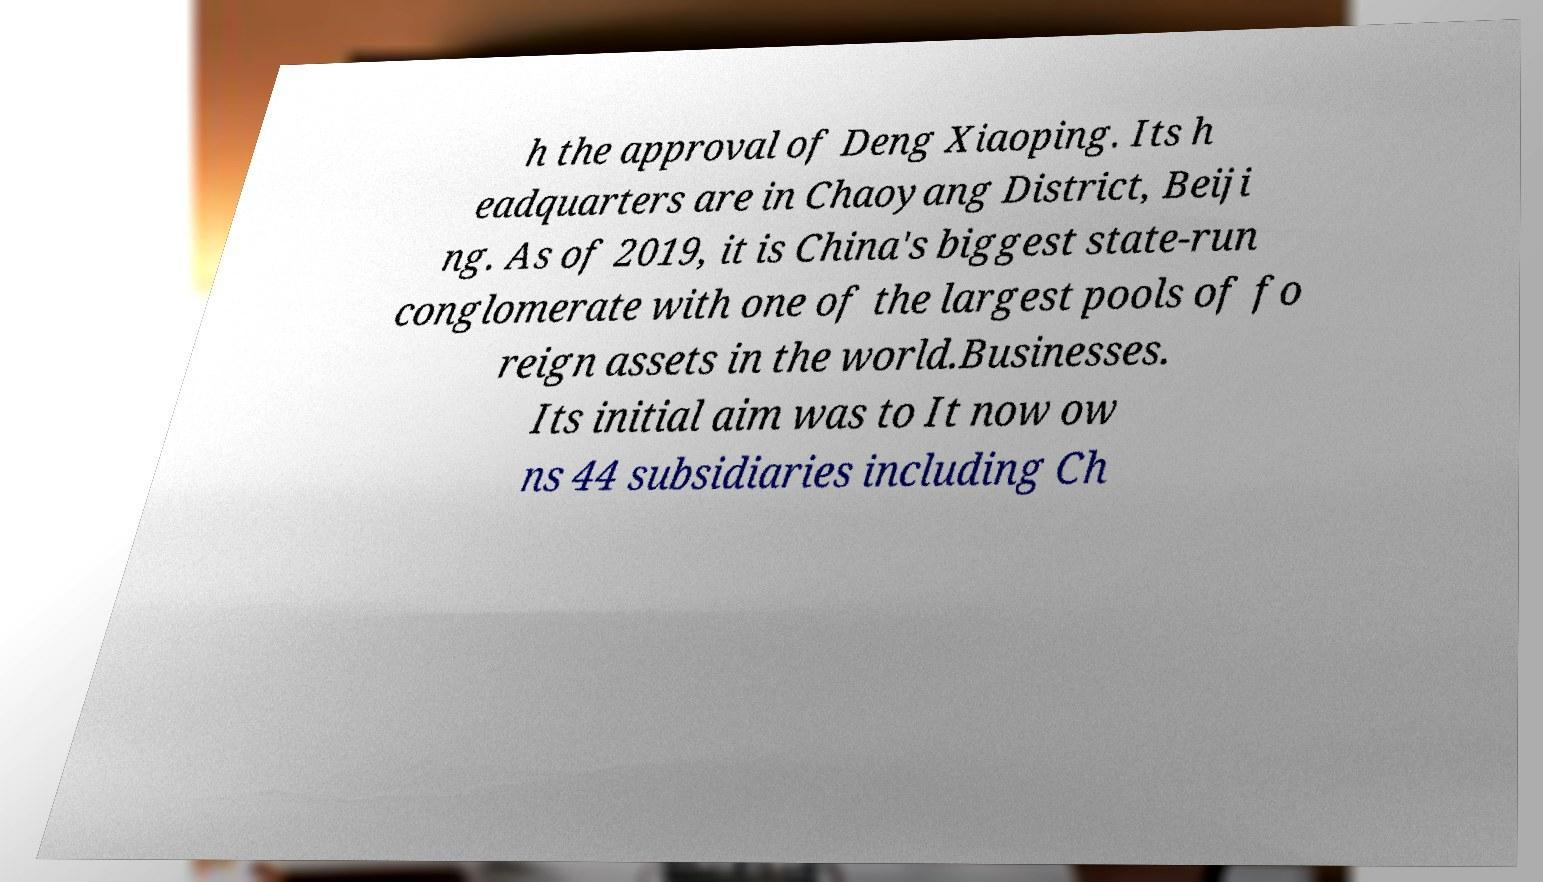Could you extract and type out the text from this image? h the approval of Deng Xiaoping. Its h eadquarters are in Chaoyang District, Beiji ng. As of 2019, it is China's biggest state-run conglomerate with one of the largest pools of fo reign assets in the world.Businesses. Its initial aim was to It now ow ns 44 subsidiaries including Ch 